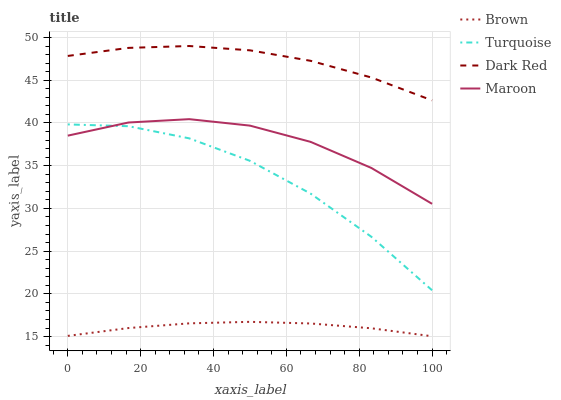Does Brown have the minimum area under the curve?
Answer yes or no. Yes. Does Dark Red have the maximum area under the curve?
Answer yes or no. Yes. Does Turquoise have the minimum area under the curve?
Answer yes or no. No. Does Turquoise have the maximum area under the curve?
Answer yes or no. No. Is Brown the smoothest?
Answer yes or no. Yes. Is Turquoise the roughest?
Answer yes or no. Yes. Is Maroon the smoothest?
Answer yes or no. No. Is Maroon the roughest?
Answer yes or no. No. Does Brown have the lowest value?
Answer yes or no. Yes. Does Turquoise have the lowest value?
Answer yes or no. No. Does Dark Red have the highest value?
Answer yes or no. Yes. Does Turquoise have the highest value?
Answer yes or no. No. Is Turquoise less than Dark Red?
Answer yes or no. Yes. Is Dark Red greater than Maroon?
Answer yes or no. Yes. Does Turquoise intersect Maroon?
Answer yes or no. Yes. Is Turquoise less than Maroon?
Answer yes or no. No. Is Turquoise greater than Maroon?
Answer yes or no. No. Does Turquoise intersect Dark Red?
Answer yes or no. No. 